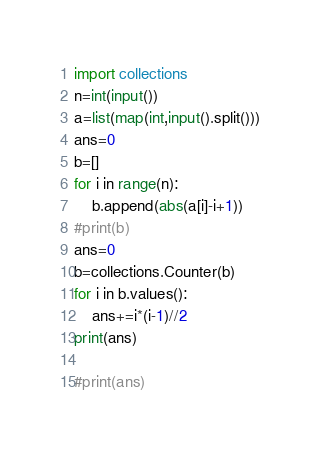<code> <loc_0><loc_0><loc_500><loc_500><_Python_>import collections
n=int(input())
a=list(map(int,input().split()))
ans=0
b=[]
for i in range(n):
    b.append(abs(a[i]-i+1))
#print(b)
ans=0
b=collections.Counter(b)
for i in b.values():
    ans+=i*(i-1)//2
print(ans)

#print(ans)</code> 